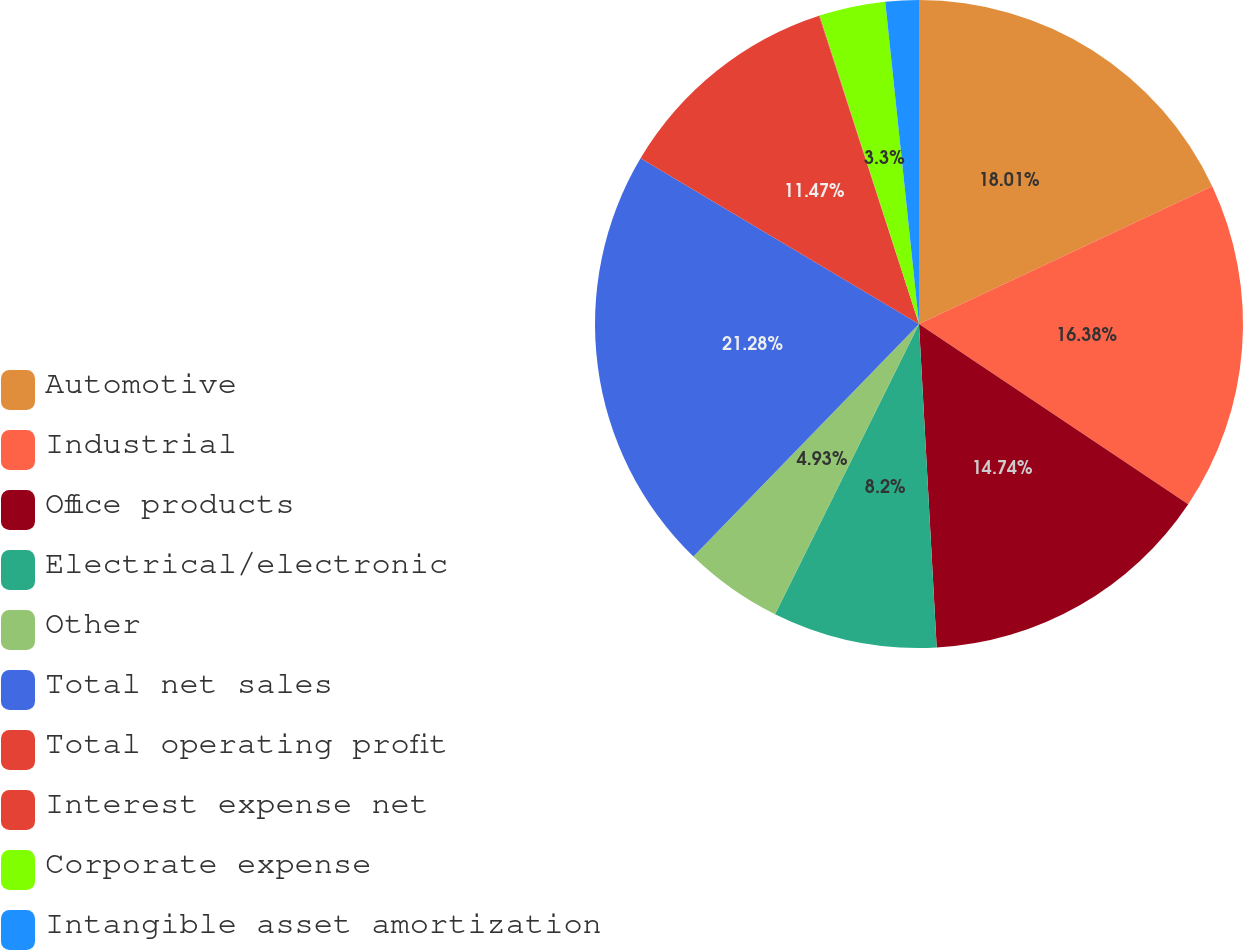<chart> <loc_0><loc_0><loc_500><loc_500><pie_chart><fcel>Automotive<fcel>Industrial<fcel>Office products<fcel>Electrical/electronic<fcel>Other<fcel>Total net sales<fcel>Total operating profit<fcel>Interest expense net<fcel>Corporate expense<fcel>Intangible asset amortization<nl><fcel>18.01%<fcel>16.38%<fcel>14.74%<fcel>8.2%<fcel>4.93%<fcel>21.28%<fcel>11.47%<fcel>0.03%<fcel>3.3%<fcel>1.66%<nl></chart> 